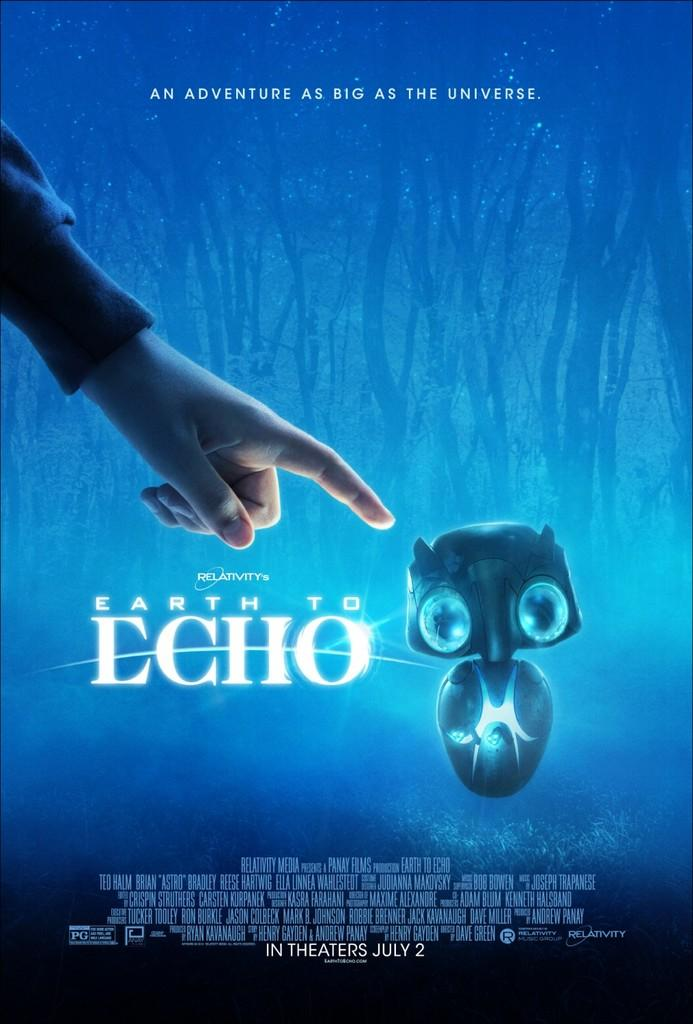Provide a one-sentence caption for the provided image. An advertisement for a movie called "earth to echo.". 